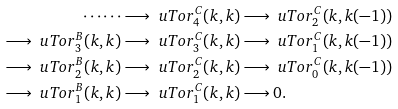Convert formula to latex. <formula><loc_0><loc_0><loc_500><loc_500>\cdots \cdots & \longrightarrow \ u T o r ^ { C } _ { 4 } ( k , k ) \longrightarrow \ u T o r ^ { C } _ { 2 } ( k , k ( - 1 ) ) \\ \longrightarrow \ u T o r ^ { B } _ { 3 } ( k , k ) & \longrightarrow \ u T o r ^ { C } _ { 3 } ( k , k ) \longrightarrow \ u T o r ^ { C } _ { 1 } ( k , k ( - 1 ) ) \\ \longrightarrow \ u T o r ^ { B } _ { 2 } ( k , k ) & \longrightarrow \ u T o r ^ { C } _ { 2 } ( k , k ) \longrightarrow \ u T o r ^ { C } _ { 0 } ( k , k ( - 1 ) ) \\ \longrightarrow \ u T o r ^ { B } _ { 1 } ( k , k ) & \longrightarrow \ u T o r ^ { C } _ { 1 } ( k , k ) \longrightarrow 0 .</formula> 